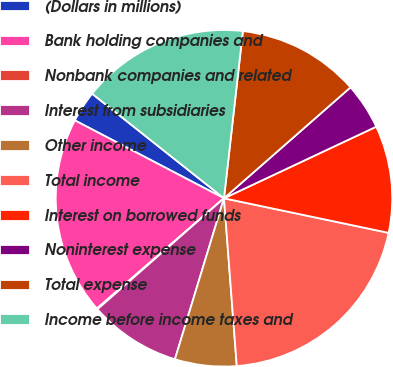<chart> <loc_0><loc_0><loc_500><loc_500><pie_chart><fcel>(Dollars in millions)<fcel>Bank holding companies and<fcel>Nonbank companies and related<fcel>Interest from subsidiaries<fcel>Other income<fcel>Total income<fcel>Interest on borrowed funds<fcel>Noninterest expense<fcel>Total expense<fcel>Income before income taxes and<nl><fcel>3.01%<fcel>19.03%<fcel>0.09%<fcel>8.83%<fcel>5.92%<fcel>20.49%<fcel>10.29%<fcel>4.46%<fcel>11.75%<fcel>16.12%<nl></chart> 